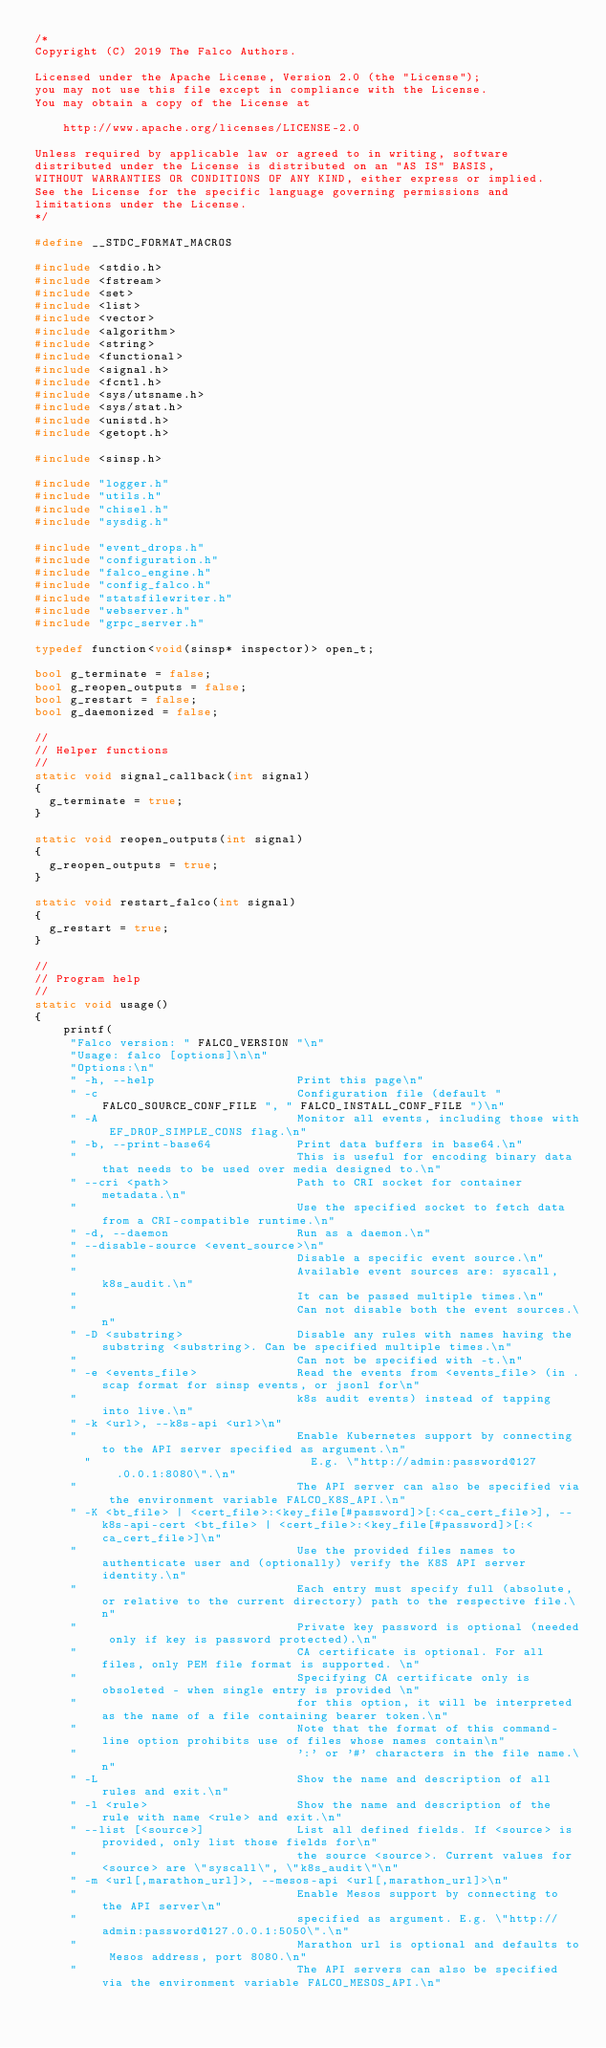<code> <loc_0><loc_0><loc_500><loc_500><_C++_>/*
Copyright (C) 2019 The Falco Authors.

Licensed under the Apache License, Version 2.0 (the "License");
you may not use this file except in compliance with the License.
You may obtain a copy of the License at

    http://www.apache.org/licenses/LICENSE-2.0

Unless required by applicable law or agreed to in writing, software
distributed under the License is distributed on an "AS IS" BASIS,
WITHOUT WARRANTIES OR CONDITIONS OF ANY KIND, either express or implied.
See the License for the specific language governing permissions and
limitations under the License.
*/

#define __STDC_FORMAT_MACROS

#include <stdio.h>
#include <fstream>
#include <set>
#include <list>
#include <vector>
#include <algorithm>
#include <string>
#include <functional>
#include <signal.h>
#include <fcntl.h>
#include <sys/utsname.h>
#include <sys/stat.h>
#include <unistd.h>
#include <getopt.h>

#include <sinsp.h>

#include "logger.h"
#include "utils.h"
#include "chisel.h"
#include "sysdig.h"

#include "event_drops.h"
#include "configuration.h"
#include "falco_engine.h"
#include "config_falco.h"
#include "statsfilewriter.h"
#include "webserver.h"
#include "grpc_server.h"

typedef function<void(sinsp* inspector)> open_t;

bool g_terminate = false;
bool g_reopen_outputs = false;
bool g_restart = false;
bool g_daemonized = false;

//
// Helper functions
//
static void signal_callback(int signal)
{
	g_terminate = true;
}

static void reopen_outputs(int signal)
{
	g_reopen_outputs = true;
}

static void restart_falco(int signal)
{
	g_restart = true;
}

//
// Program help
//
static void usage()
{
    printf(
	   "Falco version: " FALCO_VERSION "\n"
	   "Usage: falco [options]\n\n"
	   "Options:\n"
	   " -h, --help                    Print this page\n"
	   " -c                            Configuration file (default " FALCO_SOURCE_CONF_FILE ", " FALCO_INSTALL_CONF_FILE ")\n"
	   " -A                            Monitor all events, including those with EF_DROP_SIMPLE_CONS flag.\n"
	   " -b, --print-base64            Print data buffers in base64.\n"
	   "                               This is useful for encoding binary data that needs to be used over media designed to.\n"
	   " --cri <path>                  Path to CRI socket for container metadata.\n"
	   "                               Use the specified socket to fetch data from a CRI-compatible runtime.\n"
	   " -d, --daemon                  Run as a daemon.\n"
	   " --disable-source <event_source>\n"
	   "                               Disable a specific event source.\n"
	   "                               Available event sources are: syscall, k8s_audit.\n"
	   "                               It can be passed multiple times.\n"
	   "                               Can not disable both the event sources.\n"
	   " -D <substring>                Disable any rules with names having the substring <substring>. Can be specified multiple times.\n"
	   "                               Can not be specified with -t.\n"
	   " -e <events_file>              Read the events from <events_file> (in .scap format for sinsp events, or jsonl for\n"
	   "                               k8s audit events) instead of tapping into live.\n"
	   " -k <url>, --k8s-api <url>\n"
	   "                               Enable Kubernetes support by connecting to the API server specified as argument.\n"
       "                               E.g. \"http://admin:password@127.0.0.1:8080\".\n"
	   "                               The API server can also be specified via the environment variable FALCO_K8S_API.\n"
	   " -K <bt_file> | <cert_file>:<key_file[#password]>[:<ca_cert_file>], --k8s-api-cert <bt_file> | <cert_file>:<key_file[#password]>[:<ca_cert_file>]\n"
	   "                               Use the provided files names to authenticate user and (optionally) verify the K8S API server identity.\n"
	   "                               Each entry must specify full (absolute, or relative to the current directory) path to the respective file.\n"
	   "                               Private key password is optional (needed only if key is password protected).\n"
	   "                               CA certificate is optional. For all files, only PEM file format is supported. \n"
	   "                               Specifying CA certificate only is obsoleted - when single entry is provided \n"
	   "                               for this option, it will be interpreted as the name of a file containing bearer token.\n"
	   "                               Note that the format of this command-line option prohibits use of files whose names contain\n"
	   "                               ':' or '#' characters in the file name.\n"
	   " -L                            Show the name and description of all rules and exit.\n"
	   " -l <rule>                     Show the name and description of the rule with name <rule> and exit.\n"
	   " --list [<source>]             List all defined fields. If <source> is provided, only list those fields for\n"
	   "                               the source <source>. Current values for <source> are \"syscall\", \"k8s_audit\"\n"
	   " -m <url[,marathon_url]>, --mesos-api <url[,marathon_url]>\n"
	   "                               Enable Mesos support by connecting to the API server\n"
	   "                               specified as argument. E.g. \"http://admin:password@127.0.0.1:5050\".\n"
	   "                               Marathon url is optional and defaults to Mesos address, port 8080.\n"
	   "                               The API servers can also be specified via the environment variable FALCO_MESOS_API.\n"</code> 